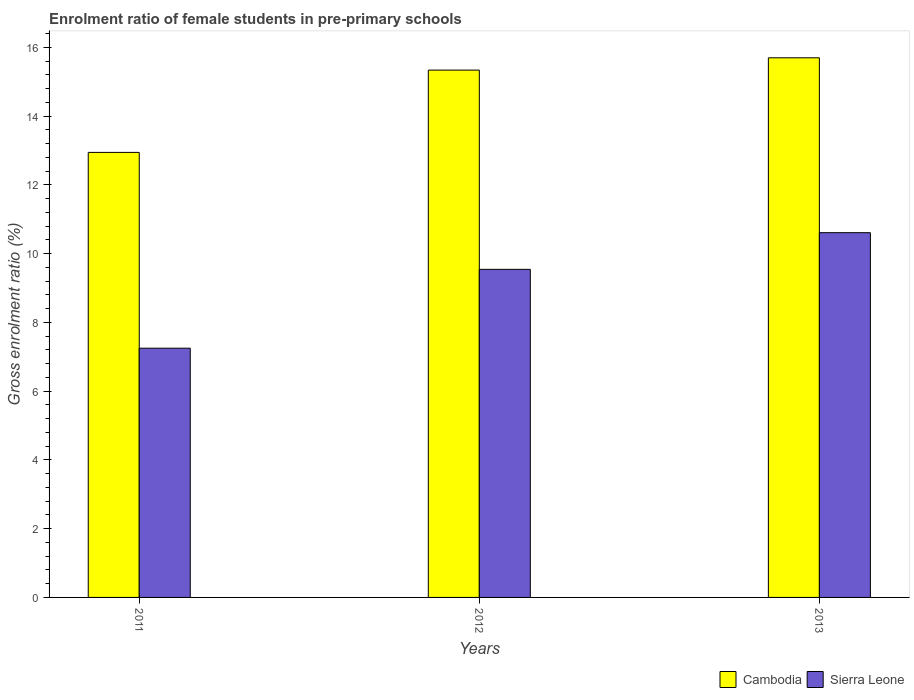How many different coloured bars are there?
Your answer should be compact. 2. Are the number of bars on each tick of the X-axis equal?
Offer a terse response. Yes. What is the label of the 2nd group of bars from the left?
Keep it short and to the point. 2012. What is the enrolment ratio of female students in pre-primary schools in Cambodia in 2012?
Give a very brief answer. 15.34. Across all years, what is the maximum enrolment ratio of female students in pre-primary schools in Sierra Leone?
Your response must be concise. 10.61. Across all years, what is the minimum enrolment ratio of female students in pre-primary schools in Cambodia?
Ensure brevity in your answer.  12.94. In which year was the enrolment ratio of female students in pre-primary schools in Cambodia maximum?
Ensure brevity in your answer.  2013. In which year was the enrolment ratio of female students in pre-primary schools in Cambodia minimum?
Keep it short and to the point. 2011. What is the total enrolment ratio of female students in pre-primary schools in Cambodia in the graph?
Provide a succinct answer. 43.97. What is the difference between the enrolment ratio of female students in pre-primary schools in Sierra Leone in 2011 and that in 2012?
Ensure brevity in your answer.  -2.29. What is the difference between the enrolment ratio of female students in pre-primary schools in Sierra Leone in 2012 and the enrolment ratio of female students in pre-primary schools in Cambodia in 2013?
Your answer should be compact. -6.15. What is the average enrolment ratio of female students in pre-primary schools in Sierra Leone per year?
Make the answer very short. 9.13. In the year 2012, what is the difference between the enrolment ratio of female students in pre-primary schools in Cambodia and enrolment ratio of female students in pre-primary schools in Sierra Leone?
Ensure brevity in your answer.  5.79. In how many years, is the enrolment ratio of female students in pre-primary schools in Sierra Leone greater than 11.2 %?
Offer a very short reply. 0. What is the ratio of the enrolment ratio of female students in pre-primary schools in Cambodia in 2011 to that in 2013?
Give a very brief answer. 0.82. Is the enrolment ratio of female students in pre-primary schools in Sierra Leone in 2011 less than that in 2013?
Keep it short and to the point. Yes. What is the difference between the highest and the second highest enrolment ratio of female students in pre-primary schools in Sierra Leone?
Your answer should be compact. 1.07. What is the difference between the highest and the lowest enrolment ratio of female students in pre-primary schools in Sierra Leone?
Provide a short and direct response. 3.36. In how many years, is the enrolment ratio of female students in pre-primary schools in Sierra Leone greater than the average enrolment ratio of female students in pre-primary schools in Sierra Leone taken over all years?
Offer a terse response. 2. Is the sum of the enrolment ratio of female students in pre-primary schools in Sierra Leone in 2011 and 2013 greater than the maximum enrolment ratio of female students in pre-primary schools in Cambodia across all years?
Your response must be concise. Yes. What does the 1st bar from the left in 2013 represents?
Keep it short and to the point. Cambodia. What does the 1st bar from the right in 2013 represents?
Your response must be concise. Sierra Leone. Are all the bars in the graph horizontal?
Keep it short and to the point. No. How many years are there in the graph?
Offer a terse response. 3. Does the graph contain any zero values?
Offer a very short reply. No. Does the graph contain grids?
Keep it short and to the point. No. Where does the legend appear in the graph?
Make the answer very short. Bottom right. How are the legend labels stacked?
Your answer should be compact. Horizontal. What is the title of the graph?
Keep it short and to the point. Enrolment ratio of female students in pre-primary schools. Does "Vanuatu" appear as one of the legend labels in the graph?
Your answer should be very brief. No. What is the label or title of the X-axis?
Offer a very short reply. Years. What is the label or title of the Y-axis?
Your response must be concise. Gross enrolment ratio (%). What is the Gross enrolment ratio (%) of Cambodia in 2011?
Give a very brief answer. 12.94. What is the Gross enrolment ratio (%) in Sierra Leone in 2011?
Make the answer very short. 7.25. What is the Gross enrolment ratio (%) of Cambodia in 2012?
Your answer should be compact. 15.34. What is the Gross enrolment ratio (%) of Sierra Leone in 2012?
Your answer should be compact. 9.54. What is the Gross enrolment ratio (%) in Cambodia in 2013?
Offer a terse response. 15.69. What is the Gross enrolment ratio (%) of Sierra Leone in 2013?
Make the answer very short. 10.61. Across all years, what is the maximum Gross enrolment ratio (%) in Cambodia?
Ensure brevity in your answer.  15.69. Across all years, what is the maximum Gross enrolment ratio (%) of Sierra Leone?
Keep it short and to the point. 10.61. Across all years, what is the minimum Gross enrolment ratio (%) in Cambodia?
Ensure brevity in your answer.  12.94. Across all years, what is the minimum Gross enrolment ratio (%) in Sierra Leone?
Offer a terse response. 7.25. What is the total Gross enrolment ratio (%) in Cambodia in the graph?
Make the answer very short. 43.97. What is the total Gross enrolment ratio (%) of Sierra Leone in the graph?
Ensure brevity in your answer.  27.4. What is the difference between the Gross enrolment ratio (%) of Cambodia in 2011 and that in 2012?
Ensure brevity in your answer.  -2.39. What is the difference between the Gross enrolment ratio (%) in Sierra Leone in 2011 and that in 2012?
Offer a very short reply. -2.29. What is the difference between the Gross enrolment ratio (%) in Cambodia in 2011 and that in 2013?
Keep it short and to the point. -2.75. What is the difference between the Gross enrolment ratio (%) of Sierra Leone in 2011 and that in 2013?
Give a very brief answer. -3.36. What is the difference between the Gross enrolment ratio (%) of Cambodia in 2012 and that in 2013?
Offer a terse response. -0.36. What is the difference between the Gross enrolment ratio (%) of Sierra Leone in 2012 and that in 2013?
Ensure brevity in your answer.  -1.07. What is the difference between the Gross enrolment ratio (%) of Cambodia in 2011 and the Gross enrolment ratio (%) of Sierra Leone in 2012?
Keep it short and to the point. 3.4. What is the difference between the Gross enrolment ratio (%) of Cambodia in 2011 and the Gross enrolment ratio (%) of Sierra Leone in 2013?
Your response must be concise. 2.33. What is the difference between the Gross enrolment ratio (%) in Cambodia in 2012 and the Gross enrolment ratio (%) in Sierra Leone in 2013?
Make the answer very short. 4.73. What is the average Gross enrolment ratio (%) of Cambodia per year?
Offer a terse response. 14.66. What is the average Gross enrolment ratio (%) of Sierra Leone per year?
Ensure brevity in your answer.  9.13. In the year 2011, what is the difference between the Gross enrolment ratio (%) in Cambodia and Gross enrolment ratio (%) in Sierra Leone?
Make the answer very short. 5.69. In the year 2012, what is the difference between the Gross enrolment ratio (%) in Cambodia and Gross enrolment ratio (%) in Sierra Leone?
Ensure brevity in your answer.  5.79. In the year 2013, what is the difference between the Gross enrolment ratio (%) in Cambodia and Gross enrolment ratio (%) in Sierra Leone?
Keep it short and to the point. 5.09. What is the ratio of the Gross enrolment ratio (%) of Cambodia in 2011 to that in 2012?
Your answer should be very brief. 0.84. What is the ratio of the Gross enrolment ratio (%) in Sierra Leone in 2011 to that in 2012?
Your answer should be very brief. 0.76. What is the ratio of the Gross enrolment ratio (%) of Cambodia in 2011 to that in 2013?
Keep it short and to the point. 0.82. What is the ratio of the Gross enrolment ratio (%) in Sierra Leone in 2011 to that in 2013?
Your answer should be very brief. 0.68. What is the ratio of the Gross enrolment ratio (%) in Cambodia in 2012 to that in 2013?
Offer a very short reply. 0.98. What is the ratio of the Gross enrolment ratio (%) of Sierra Leone in 2012 to that in 2013?
Make the answer very short. 0.9. What is the difference between the highest and the second highest Gross enrolment ratio (%) of Cambodia?
Keep it short and to the point. 0.36. What is the difference between the highest and the second highest Gross enrolment ratio (%) of Sierra Leone?
Keep it short and to the point. 1.07. What is the difference between the highest and the lowest Gross enrolment ratio (%) of Cambodia?
Ensure brevity in your answer.  2.75. What is the difference between the highest and the lowest Gross enrolment ratio (%) in Sierra Leone?
Offer a very short reply. 3.36. 